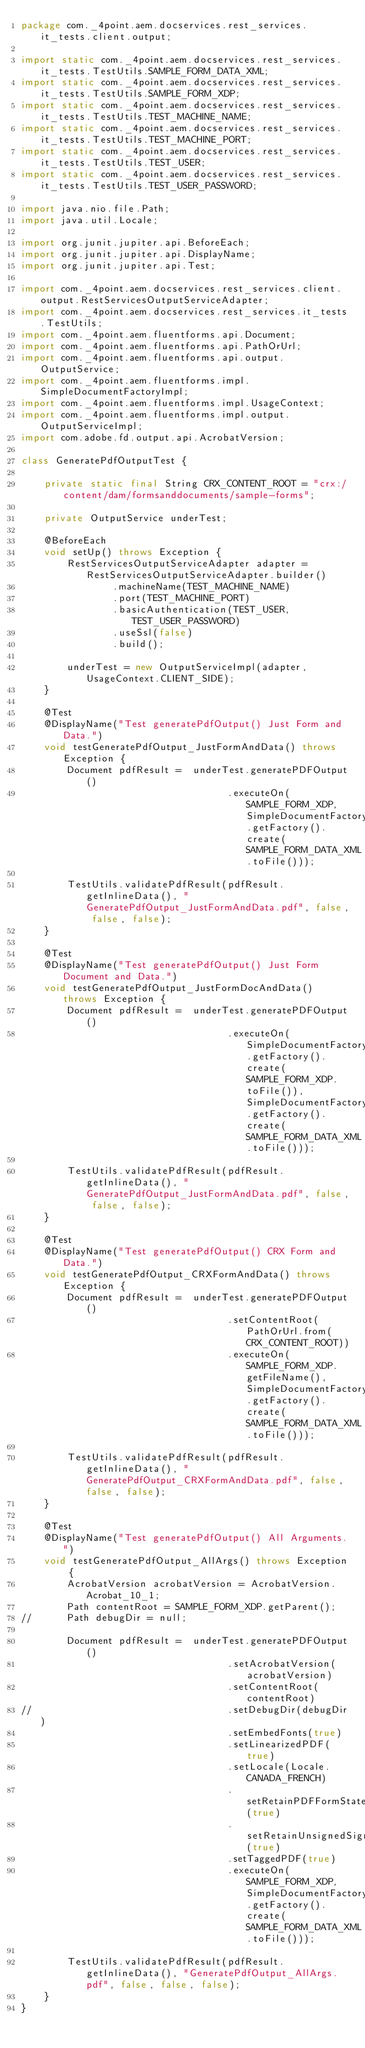Convert code to text. <code><loc_0><loc_0><loc_500><loc_500><_Java_>package com._4point.aem.docservices.rest_services.it_tests.client.output;

import static com._4point.aem.docservices.rest_services.it_tests.TestUtils.SAMPLE_FORM_DATA_XML;
import static com._4point.aem.docservices.rest_services.it_tests.TestUtils.SAMPLE_FORM_XDP;
import static com._4point.aem.docservices.rest_services.it_tests.TestUtils.TEST_MACHINE_NAME;
import static com._4point.aem.docservices.rest_services.it_tests.TestUtils.TEST_MACHINE_PORT;
import static com._4point.aem.docservices.rest_services.it_tests.TestUtils.TEST_USER;
import static com._4point.aem.docservices.rest_services.it_tests.TestUtils.TEST_USER_PASSWORD;

import java.nio.file.Path;
import java.util.Locale;

import org.junit.jupiter.api.BeforeEach;
import org.junit.jupiter.api.DisplayName;
import org.junit.jupiter.api.Test;

import com._4point.aem.docservices.rest_services.client.output.RestServicesOutputServiceAdapter;
import com._4point.aem.docservices.rest_services.it_tests.TestUtils;
import com._4point.aem.fluentforms.api.Document;
import com._4point.aem.fluentforms.api.PathOrUrl;
import com._4point.aem.fluentforms.api.output.OutputService;
import com._4point.aem.fluentforms.impl.SimpleDocumentFactoryImpl;
import com._4point.aem.fluentforms.impl.UsageContext;
import com._4point.aem.fluentforms.impl.output.OutputServiceImpl;
import com.adobe.fd.output.api.AcrobatVersion;

class GeneratePdfOutputTest {

	private static final String CRX_CONTENT_ROOT = "crx:/content/dam/formsanddocuments/sample-forms";

	private OutputService underTest;
	
	@BeforeEach
	void setUp() throws Exception {
		RestServicesOutputServiceAdapter adapter = RestServicesOutputServiceAdapter.builder()
				.machineName(TEST_MACHINE_NAME)
				.port(TEST_MACHINE_PORT)
				.basicAuthentication(TEST_USER, TEST_USER_PASSWORD)
				.useSsl(false)
				.build();

		underTest = new OutputServiceImpl(adapter, UsageContext.CLIENT_SIDE);
	}

	@Test
	@DisplayName("Test generatePdfOutput() Just Form and Data.")
	void testGeneratePdfOutput_JustFormAndData() throws Exception {
		Document pdfResult =  underTest.generatePDFOutput()
									.executeOn(SAMPLE_FORM_XDP, SimpleDocumentFactoryImpl.getFactory().create(SAMPLE_FORM_DATA_XML.toFile()));
		
		TestUtils.validatePdfResult(pdfResult.getInlineData(), "GeneratePdfOutput_JustFormAndData.pdf", false, false, false);
	}

	@Test
	@DisplayName("Test generatePdfOutput() Just Form Document and Data.")
	void testGeneratePdfOutput_JustFormDocAndData() throws Exception {
		Document pdfResult =  underTest.generatePDFOutput()
									.executeOn(SimpleDocumentFactoryImpl.getFactory().create(SAMPLE_FORM_XDP.toFile()), SimpleDocumentFactoryImpl.getFactory().create(SAMPLE_FORM_DATA_XML.toFile()));
		
		TestUtils.validatePdfResult(pdfResult.getInlineData(), "GeneratePdfOutput_JustFormAndData.pdf", false, false, false);
	}

	@Test
	@DisplayName("Test generatePdfOutput() CRX Form and Data.")
	void testGeneratePdfOutput_CRXFormAndData() throws Exception {
		Document pdfResult =  underTest.generatePDFOutput()
									.setContentRoot(PathOrUrl.from(CRX_CONTENT_ROOT))
									.executeOn(SAMPLE_FORM_XDP.getFileName(), SimpleDocumentFactoryImpl.getFactory().create(SAMPLE_FORM_DATA_XML.toFile()));
		
		TestUtils.validatePdfResult(pdfResult.getInlineData(), "GeneratePdfOutput_CRXFormAndData.pdf", false, false, false);		
	}

	@Test
	@DisplayName("Test generatePdfOutput() All Arguments.")
	void testGeneratePdfOutput_AllArgs() throws Exception {
		AcrobatVersion acrobatVersion = AcrobatVersion.Acrobat_10_1;
		Path contentRoot = SAMPLE_FORM_XDP.getParent();
//		Path debugDir = null;
		
		Document pdfResult =  underTest.generatePDFOutput()
									.setAcrobatVersion(acrobatVersion)
									.setContentRoot(contentRoot)
//									.setDebugDir(debugDir)
									.setEmbedFonts(true)
									.setLinearizedPDF(true)
									.setLocale(Locale.CANADA_FRENCH)
									.setRetainPDFFormState(true)
									.setRetainUnsignedSignatureFields(true)
									.setTaggedPDF(true)
									.executeOn(SAMPLE_FORM_XDP, SimpleDocumentFactoryImpl.getFactory().create(SAMPLE_FORM_DATA_XML.toFile()));
		
		TestUtils.validatePdfResult(pdfResult.getInlineData(), "GeneratePdfOutput_AllArgs.pdf", false, false, false);		
	}
}
</code> 